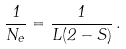Convert formula to latex. <formula><loc_0><loc_0><loc_500><loc_500>\frac { 1 } { N _ { e } } = \frac { 1 } { L ( 2 - S ) } \, .</formula> 